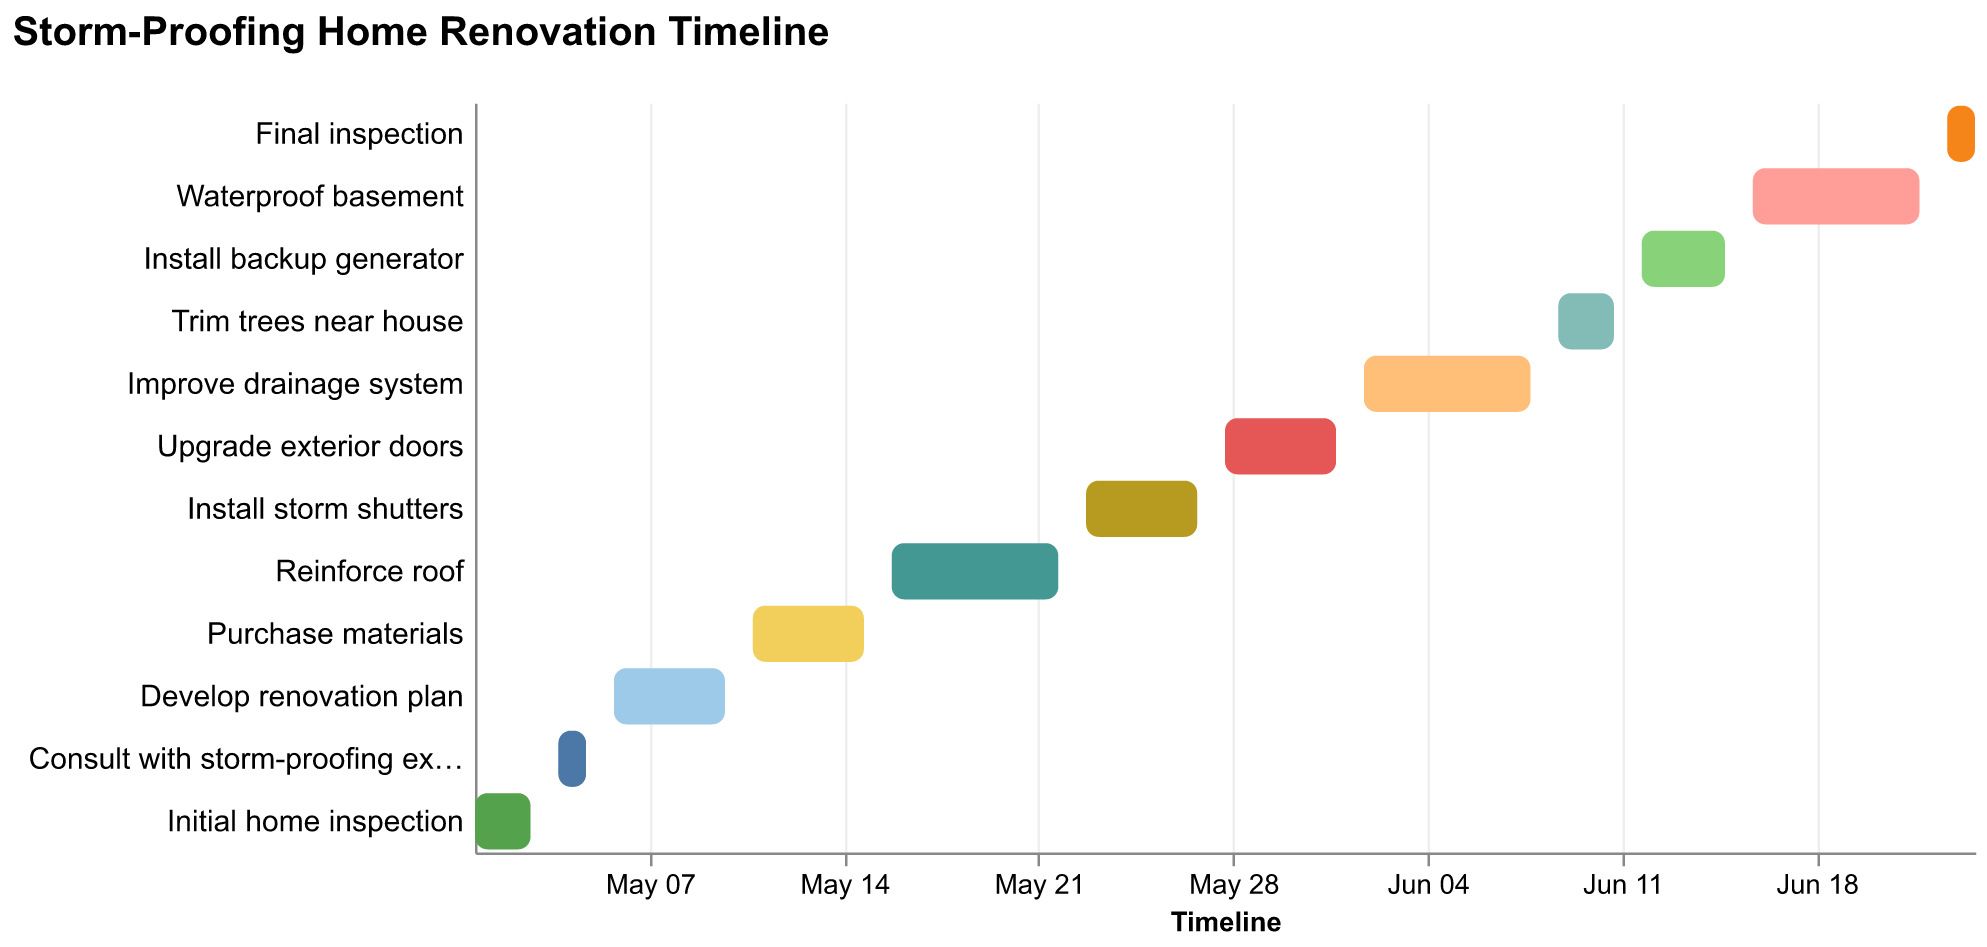What is the duration of the "Reinforce roof" task? The "Reinforce roof" task starts on 2023-05-16 and ends on 2023-05-22. The duration can be calculated by counting the number of days between these dates.
Answer: 7 days Which task finishes immediately before "Develop renovation plan" starts? By looking at the timeline, the "Consult with storm-proofing expert" task ends on 2023-05-05, and the "Develop renovation plan" task starts on 2023-05-06. Thus, "Consult with storm-proofing expert" finishes immediately before "Develop renovation plan" starts.
Answer: Consult with storm-proofing expert How many tasks are scheduled in the month of June? Tasks scheduled in June include "Upgrade exterior doors" (ends 2023-06-01), "Improve drainage system" (2023-06-02 to 2023-06-08), "Trim trees near house" (2023-06-09 to 2023-06-11), "Install backup generator" (2023-06-12 to 2023-06-15), "Waterproof basement" (2023-06-16 to 2023-06-22), and "Final inspection" (2023-06-23 to 2023-06-24). Counting these, there are six tasks.
Answer: 6 tasks Which task has the shortest duration? Comparing the durations, the shortest task is "Consult with storm-proofing expert," which spans only two days from 2023-05-04 to 2023-05-05.
Answer: Consult with storm-proofing expert Which tasks overlap with "Install storm shutters"? The "Install storm shutters" task runs from 2023-05-23 to 2023-05-27. Checking the timeline, it overlaps with "Reinforce roof" (ends on 2023-05-22) and "Upgrade exterior doors" (starts on 2023-05-28), so no other tasks overlap with it.
Answer: None What is the total length of the renovation project from start to finish? The project starts on 2023-05-01 with the "Initial home inspection" and ends on 2023-06-24 with the "Final inspection." The total duration can be calculated by counting the number of days between these dates.
Answer: 55 days When does the task "Trim trees near house" begin and end? According to the timeline, the "Trim trees near house" task begins on 2023-06-09 and ends on 2023-06-11.
Answer: 2023-06-09 to 2023-06-11 Is there any break in the schedule where no tasks are being performed? By analyzing the Gantt chart carefully, you can see that there are no gaps between tasks; each task starts immediately after the previous one ends.
Answer: No 